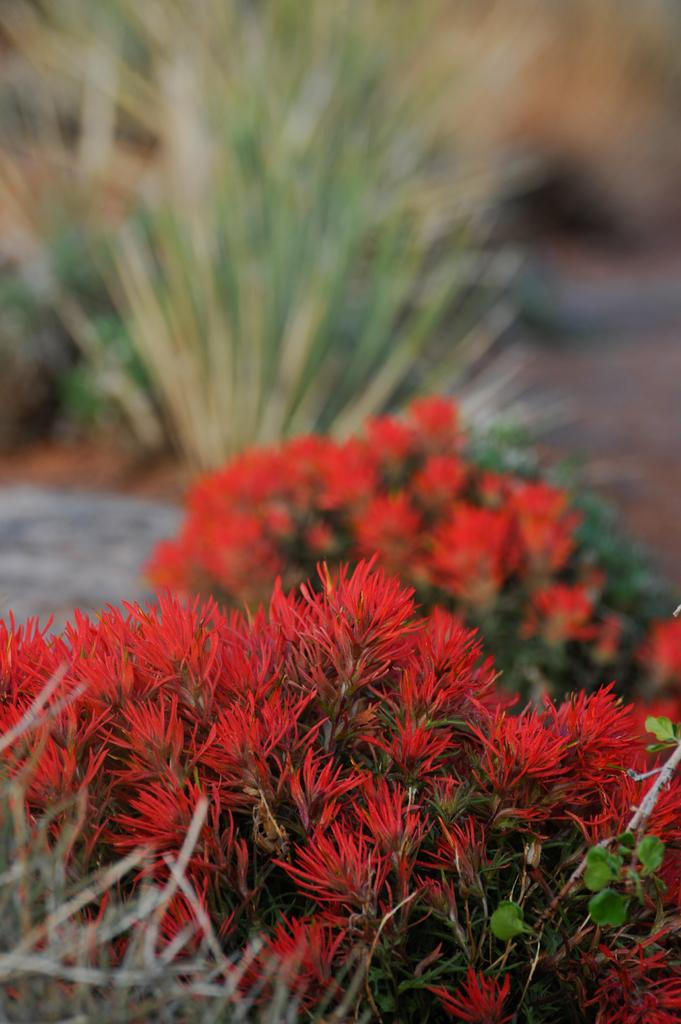What types of vegetation are present at the bottom of the image? There are plants and flowers at the bottom of the image. Can you describe the vegetation in the background of the image? There are plants visible in the background of the image. What type of terrain can be seen in the background of the image? There is land visible in the background of the image. What type of fruit is being picked in the image? There is no fruit or action of picking fruit present in the image. 